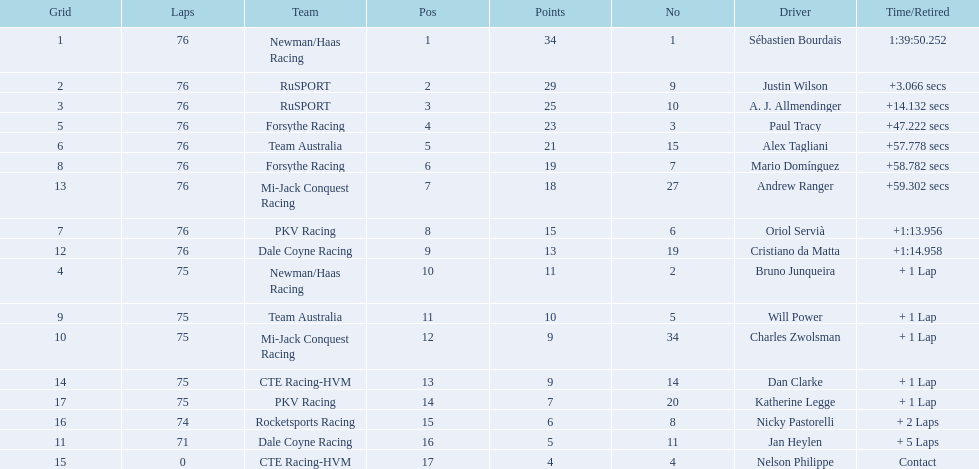What drivers took part in the 2006 tecate grand prix of monterrey? Sébastien Bourdais, Justin Wilson, A. J. Allmendinger, Paul Tracy, Alex Tagliani, Mario Domínguez, Andrew Ranger, Oriol Servià, Cristiano da Matta, Bruno Junqueira, Will Power, Charles Zwolsman, Dan Clarke, Katherine Legge, Nicky Pastorelli, Jan Heylen, Nelson Philippe. Which of those drivers scored the same amount of points as another driver? Charles Zwolsman, Dan Clarke. Who had the same amount of points as charles zwolsman? Dan Clarke. 